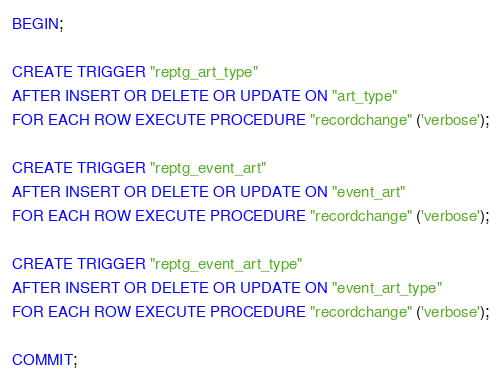Convert code to text. <code><loc_0><loc_0><loc_500><loc_500><_SQL_>BEGIN;

CREATE TRIGGER "reptg_art_type"
AFTER INSERT OR DELETE OR UPDATE ON "art_type"
FOR EACH ROW EXECUTE PROCEDURE "recordchange" ('verbose');

CREATE TRIGGER "reptg_event_art"
AFTER INSERT OR DELETE OR UPDATE ON "event_art"
FOR EACH ROW EXECUTE PROCEDURE "recordchange" ('verbose');

CREATE TRIGGER "reptg_event_art_type"
AFTER INSERT OR DELETE OR UPDATE ON "event_art_type"
FOR EACH ROW EXECUTE PROCEDURE "recordchange" ('verbose');

COMMIT;
</code> 